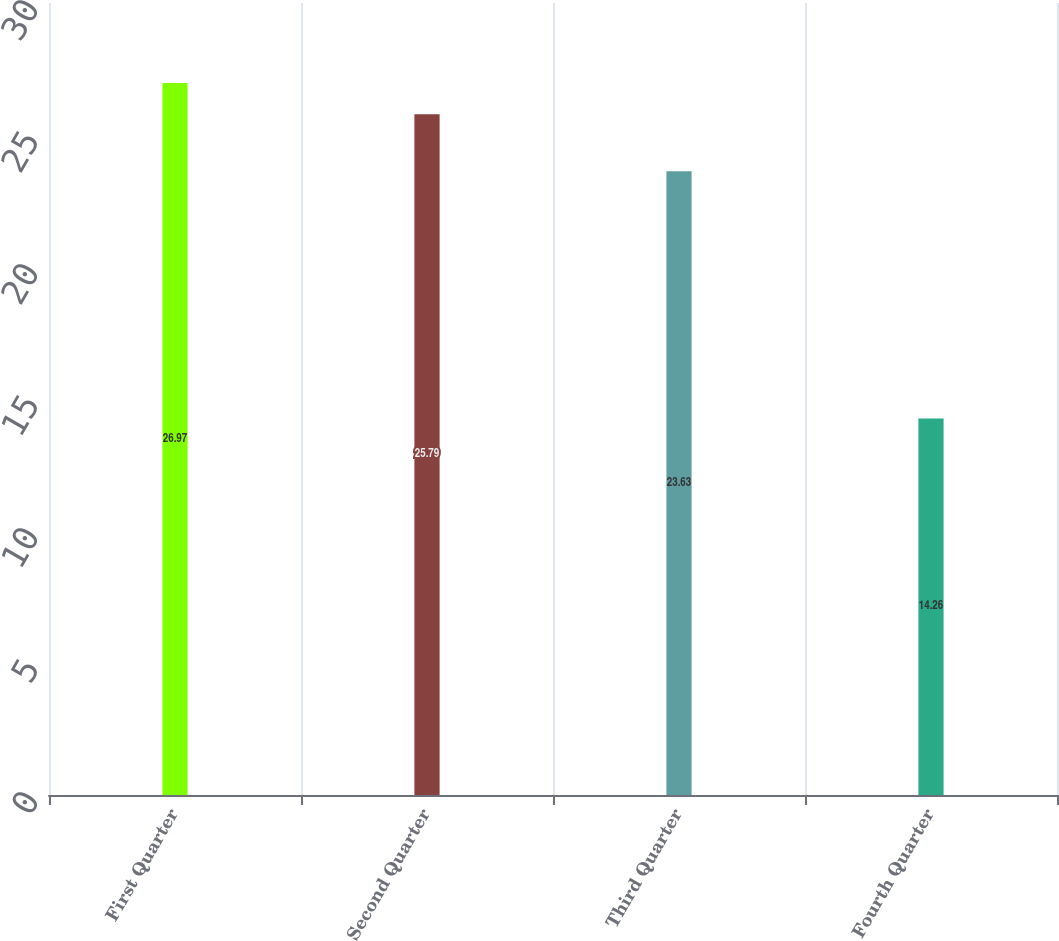<chart> <loc_0><loc_0><loc_500><loc_500><bar_chart><fcel>First Quarter<fcel>Second Quarter<fcel>Third Quarter<fcel>Fourth Quarter<nl><fcel>26.97<fcel>25.79<fcel>23.63<fcel>14.26<nl></chart> 